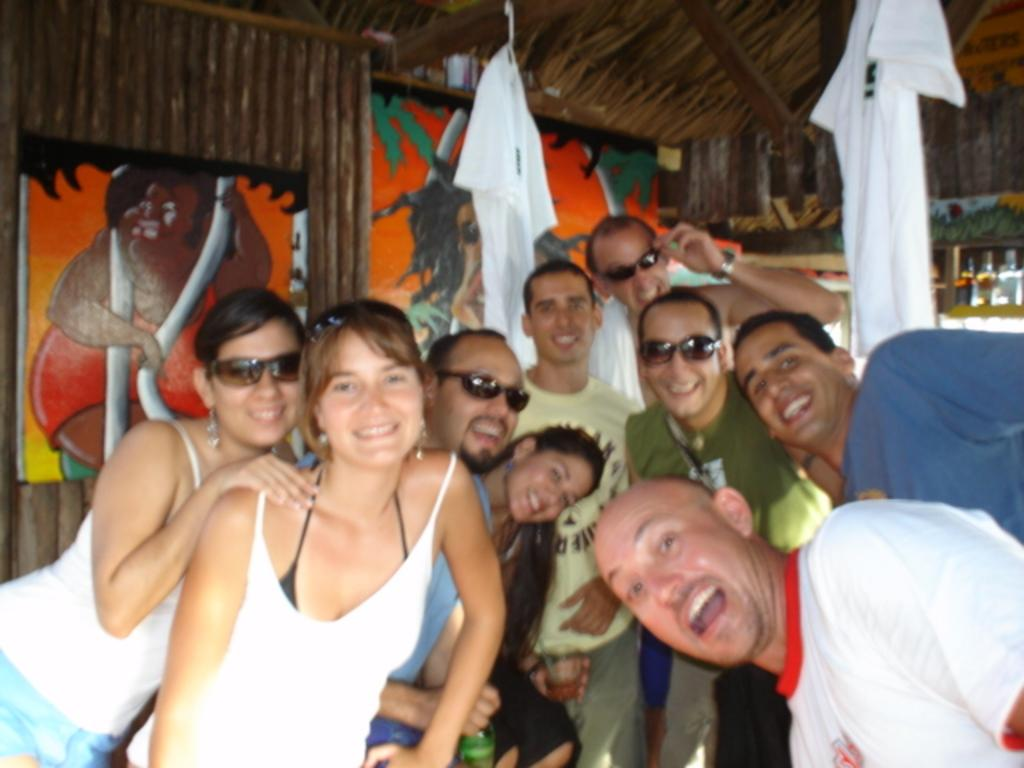How many people are present in the image? There are many people in the image. What protective gear are some people wearing? Some people are wearing goggles. What type of clothing can be seen hanging in the image? There are dresses hung in the image. What can be seen in the background of the image? There are bottles visible in the background. What type of walls are present in the image? There are wooden walls with photo frames in the image. What type of tank is visible in the image? There is no tank present in the image. Can you describe the intricate details of the dresses in the image? The provided facts do not mention any intricate details of the dresses, only that they are hung in the image. 